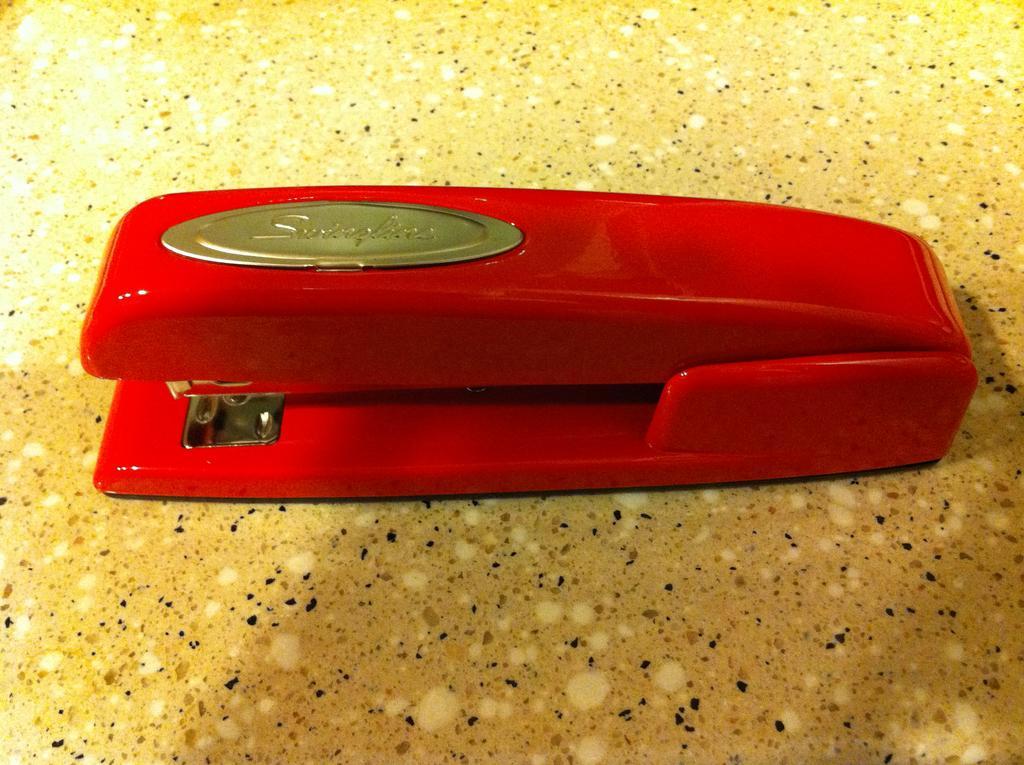How would you summarize this image in a sentence or two? In the image we can see a stapler, red in color. On it there is a batch. 